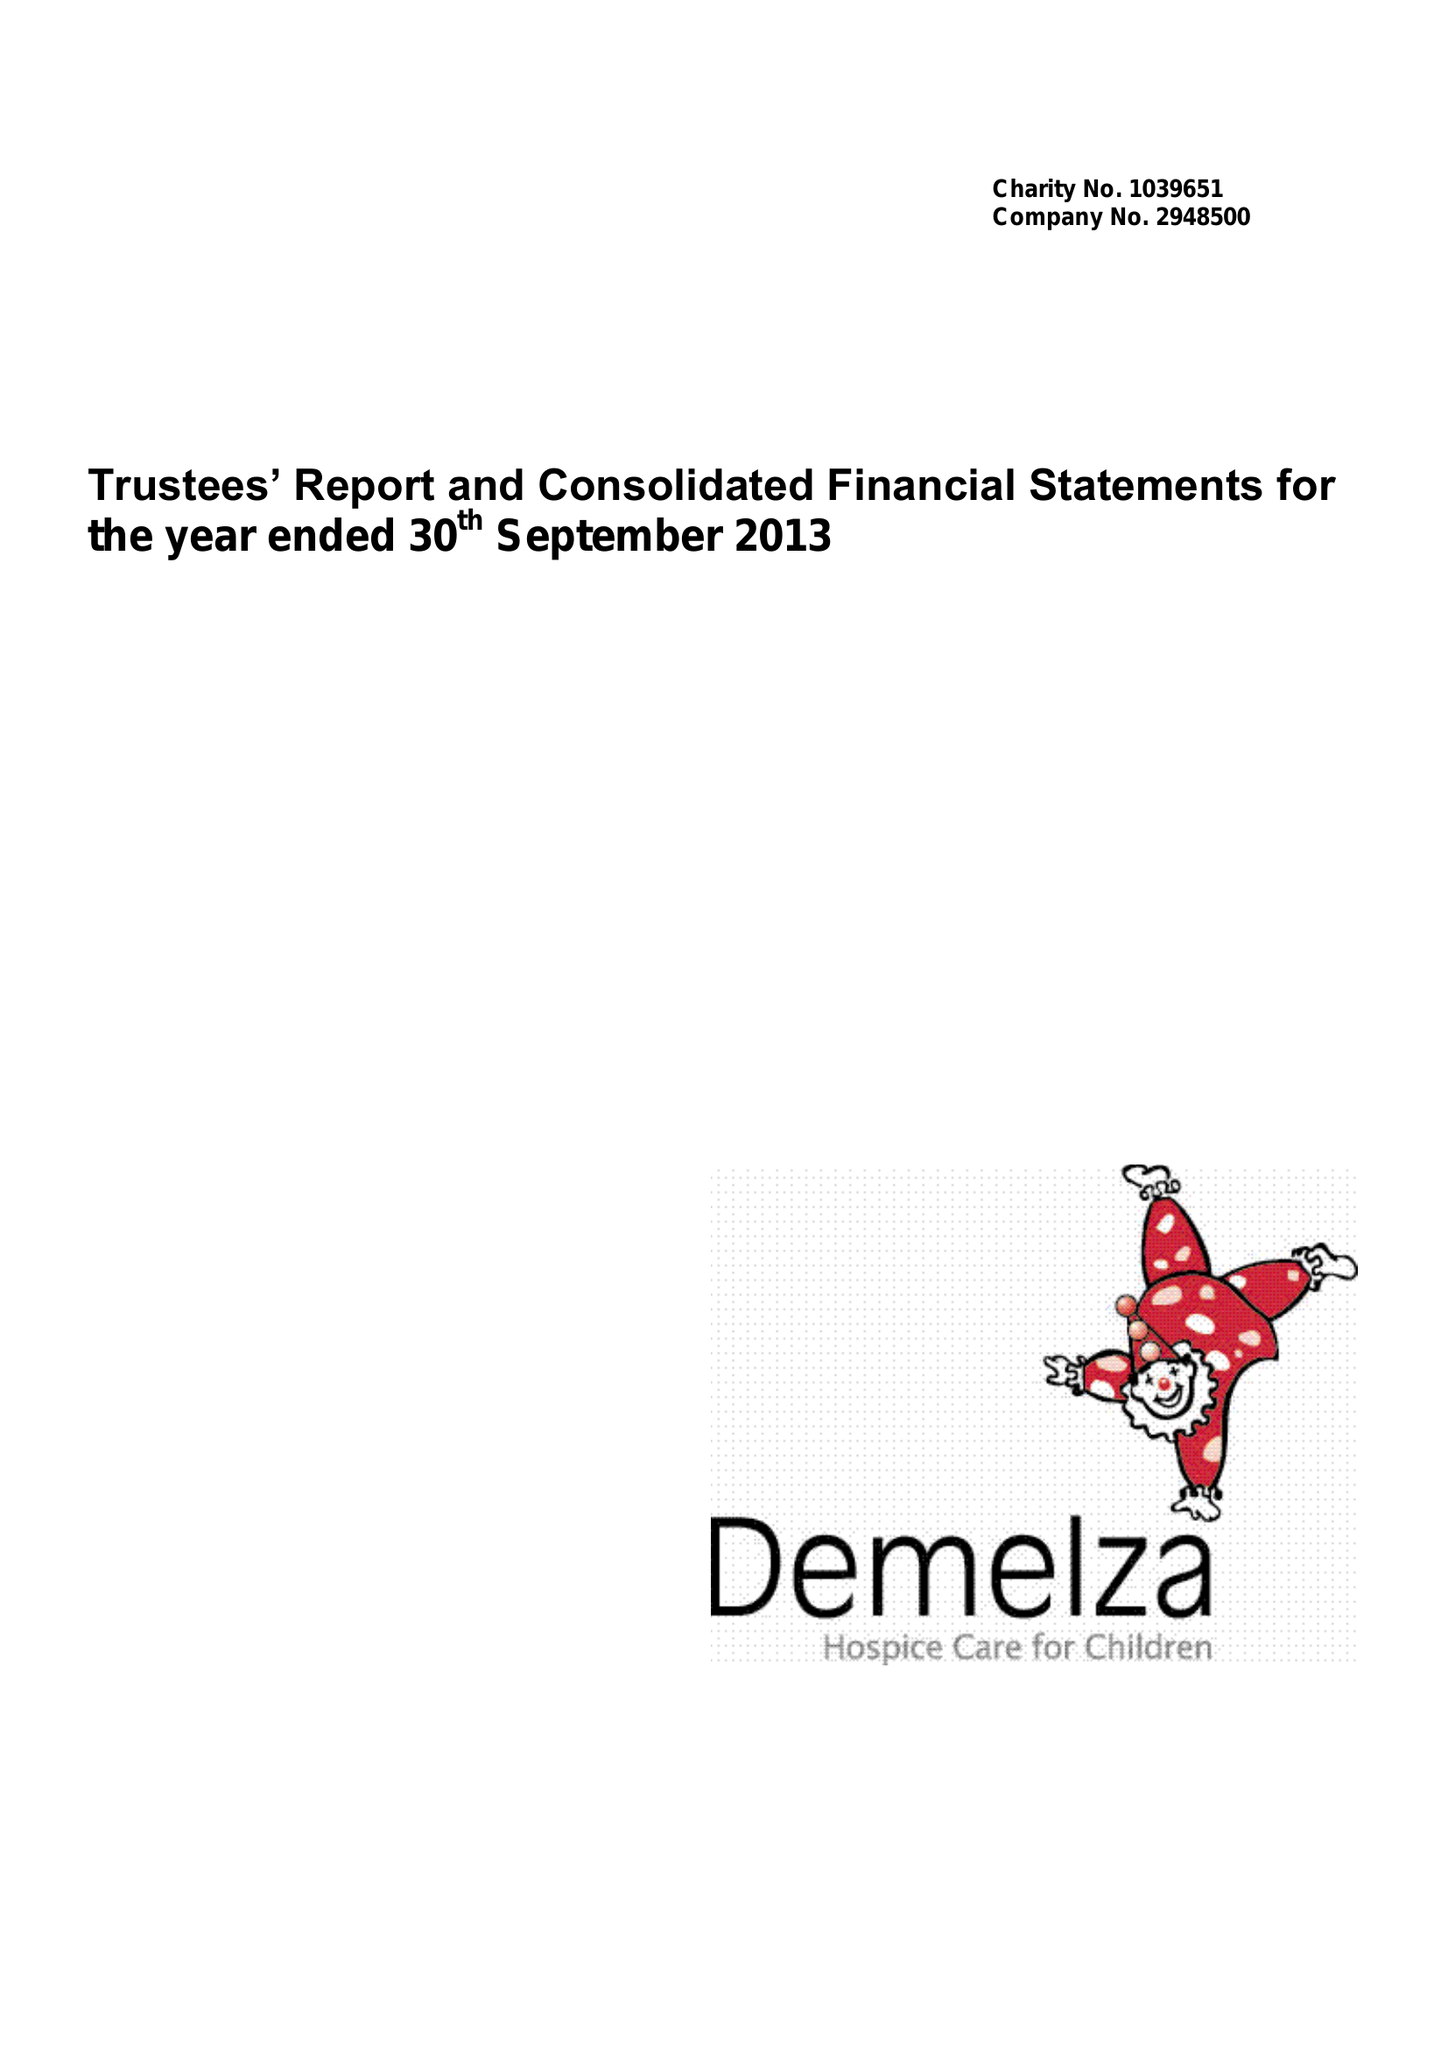What is the value for the address__post_town?
Answer the question using a single word or phrase. SITTINGBOURNE 